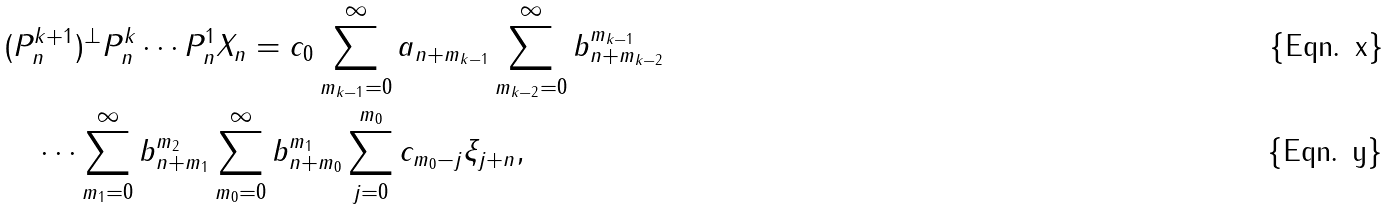<formula> <loc_0><loc_0><loc_500><loc_500>& ( P _ { n } ^ { k + 1 } ) ^ { \bot } P _ { n } ^ { k } \cdots P _ { n } ^ { 1 } X _ { n } = c _ { 0 } \sum _ { m _ { k - 1 } = 0 } ^ { \infty } a _ { n + m _ { k - 1 } } \sum _ { m _ { k - 2 } = 0 } ^ { \infty } b ^ { m _ { k - 1 } } _ { n + m _ { k - 2 } } \\ & \quad \cdots \sum _ { m _ { 1 } = 0 } ^ { \infty } b ^ { m _ { 2 } } _ { n + m _ { 1 } } \sum _ { m _ { 0 } = 0 } ^ { \infty } b ^ { m _ { 1 } } _ { n + m _ { 0 } } \sum _ { j = 0 } ^ { m _ { 0 } } c _ { m _ { 0 } - j } \xi _ { j + n } ,</formula> 